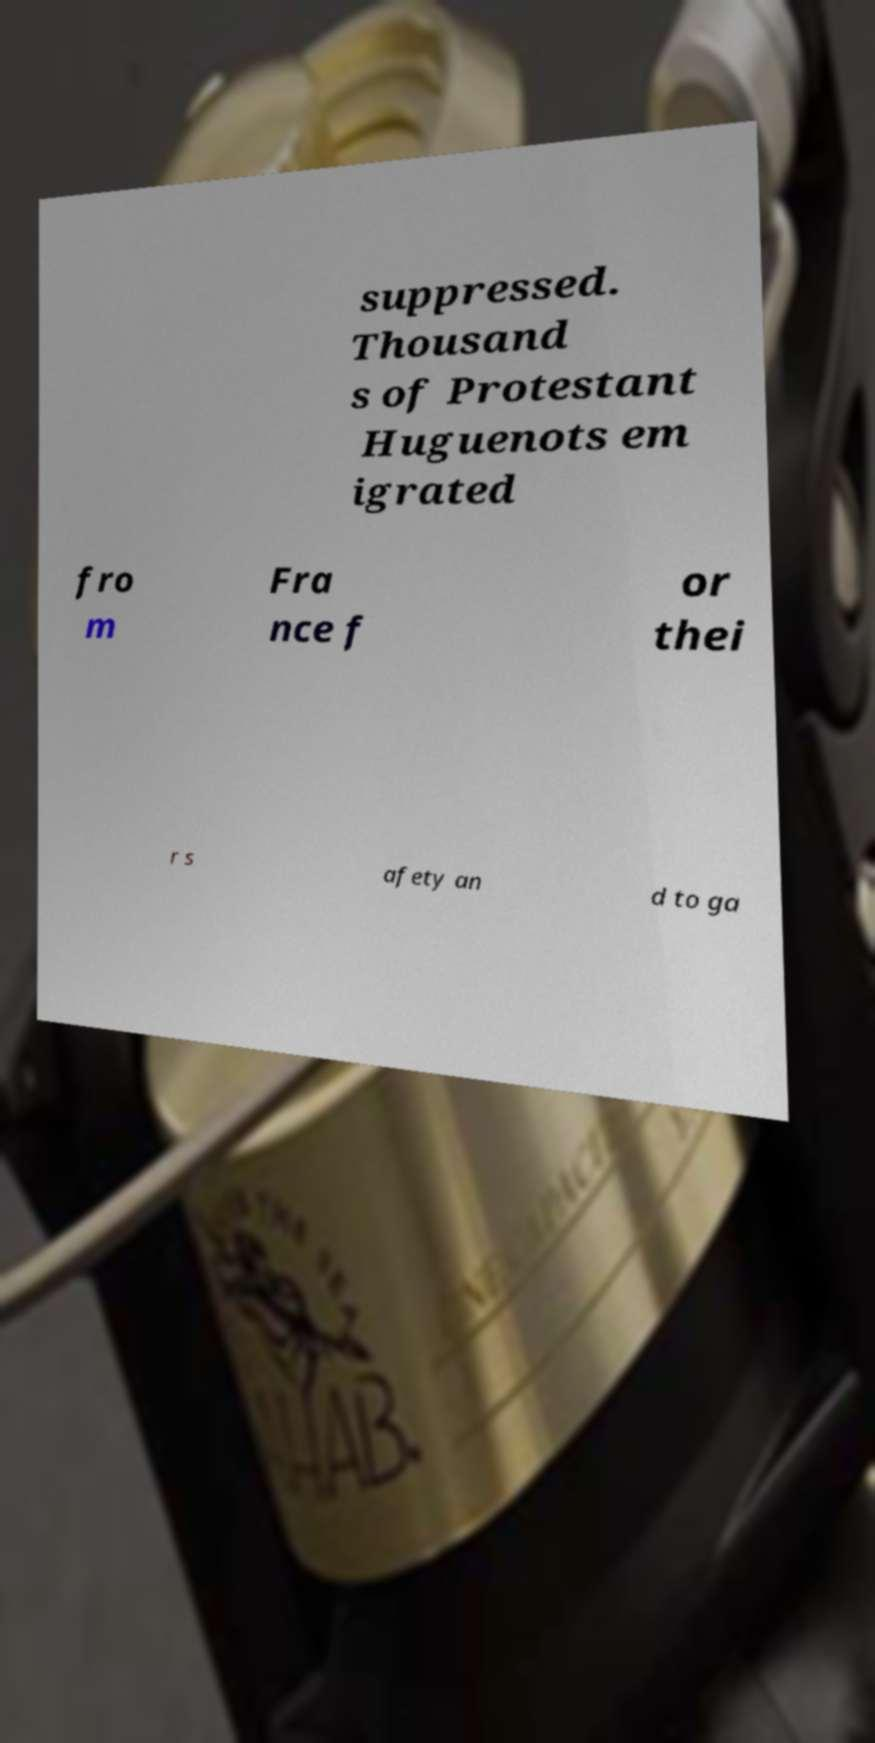Could you assist in decoding the text presented in this image and type it out clearly? suppressed. Thousand s of Protestant Huguenots em igrated fro m Fra nce f or thei r s afety an d to ga 